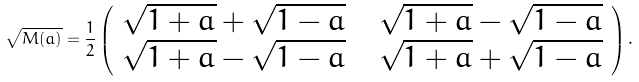Convert formula to latex. <formula><loc_0><loc_0><loc_500><loc_500>\sqrt { M ( a ) } = \frac { 1 } { 2 } \left ( \begin{array} { c c c } \sqrt { 1 + a } + \sqrt { 1 - a } & & \sqrt { 1 + a } - \sqrt { 1 - a } \\ \sqrt { 1 + a } - \sqrt { 1 - a } & & \sqrt { 1 + a } + \sqrt { 1 - a } \end{array} \right ) .</formula> 